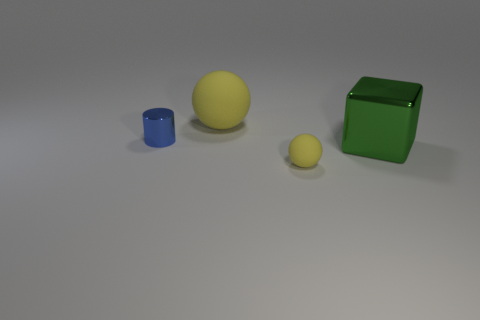Are there any large matte balls of the same color as the small matte thing?
Provide a succinct answer. Yes. Does the ball that is behind the tiny yellow matte thing have the same color as the tiny rubber sphere?
Offer a very short reply. Yes. There is a tiny matte thing; is its color the same as the ball that is behind the blue cylinder?
Provide a short and direct response. Yes. What shape is the small thing that is the same color as the large matte ball?
Give a very brief answer. Sphere. What size is the other matte sphere that is the same color as the big ball?
Ensure brevity in your answer.  Small. Do the big yellow matte thing and the small yellow rubber object have the same shape?
Give a very brief answer. Yes. There is another rubber object that is the same shape as the tiny yellow matte object; what is its size?
Your answer should be compact. Large. Does the tiny yellow thing have the same shape as the yellow thing that is behind the large green metal block?
Provide a short and direct response. Yes. There is a yellow object that is in front of the blue cylinder; does it have the same shape as the large rubber object?
Provide a succinct answer. Yes. Are there the same number of yellow matte things right of the tiny matte object and tiny blue cylinders?
Your answer should be very brief. No. 